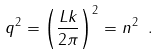Convert formula to latex. <formula><loc_0><loc_0><loc_500><loc_500>q ^ { 2 } = \left ( \frac { L k } { 2 \pi } \right ) ^ { 2 } = n ^ { 2 } \ .</formula> 